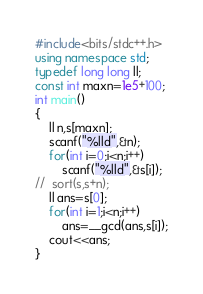Convert code to text. <code><loc_0><loc_0><loc_500><loc_500><_C++_>#include<bits/stdc++.h>
using namespace std;
typedef long long ll;
const int maxn=1e5+100;
int main()
{
	ll n,s[maxn];
	scanf("%lld",&n);
	for(int i=0;i<n;i++)
		scanf("%lld",&s[i]);
//	sort(s,s+n);
	ll ans=s[0];
	for(int i=1;i<n;i++)
		ans=__gcd(ans,s[i]);
	cout<<ans;
}</code> 